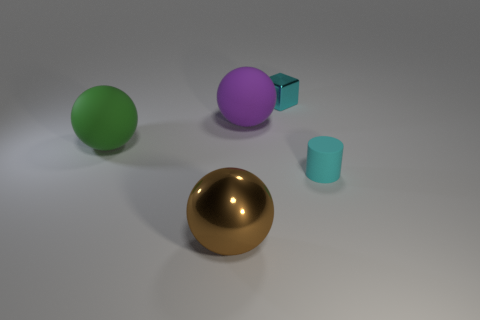How many other things are there of the same shape as the big purple thing?
Your answer should be very brief. 2. What shape is the cyan object that is the same material as the purple object?
Your answer should be compact. Cylinder. Are there any purple rubber things?
Ensure brevity in your answer.  Yes. Are there fewer cyan rubber cylinders that are behind the small cyan cube than metal cubes that are on the right side of the tiny cyan cylinder?
Offer a terse response. No. What is the shape of the metal thing in front of the cyan metal thing?
Offer a terse response. Sphere. Is the material of the small cyan block the same as the large brown thing?
Make the answer very short. Yes. Are there any other things that are made of the same material as the cyan cylinder?
Provide a succinct answer. Yes. What is the material of the big green thing that is the same shape as the large brown shiny object?
Provide a short and direct response. Rubber. Are there fewer green rubber balls in front of the cyan metal block than large purple metal balls?
Your answer should be compact. No. What number of small things are behind the purple object?
Give a very brief answer. 1. 